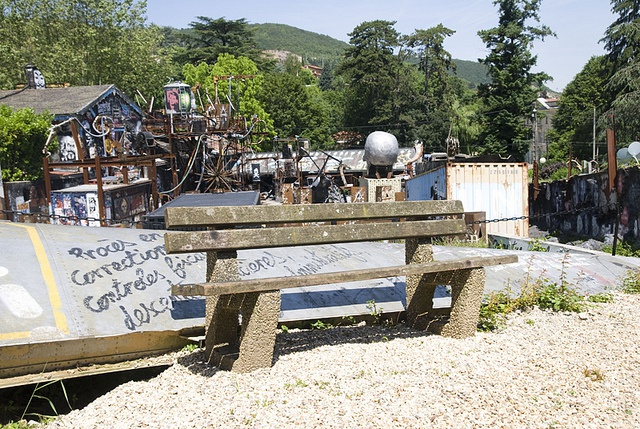Describe the objects in this image and their specific colors. I can see a bench in gray, lightgray, tan, black, and darkgray tones in this image. 